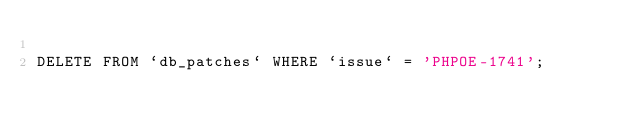Convert code to text. <code><loc_0><loc_0><loc_500><loc_500><_SQL_>
DELETE FROM `db_patches` WHERE `issue` = 'PHPOE-1741';
</code> 